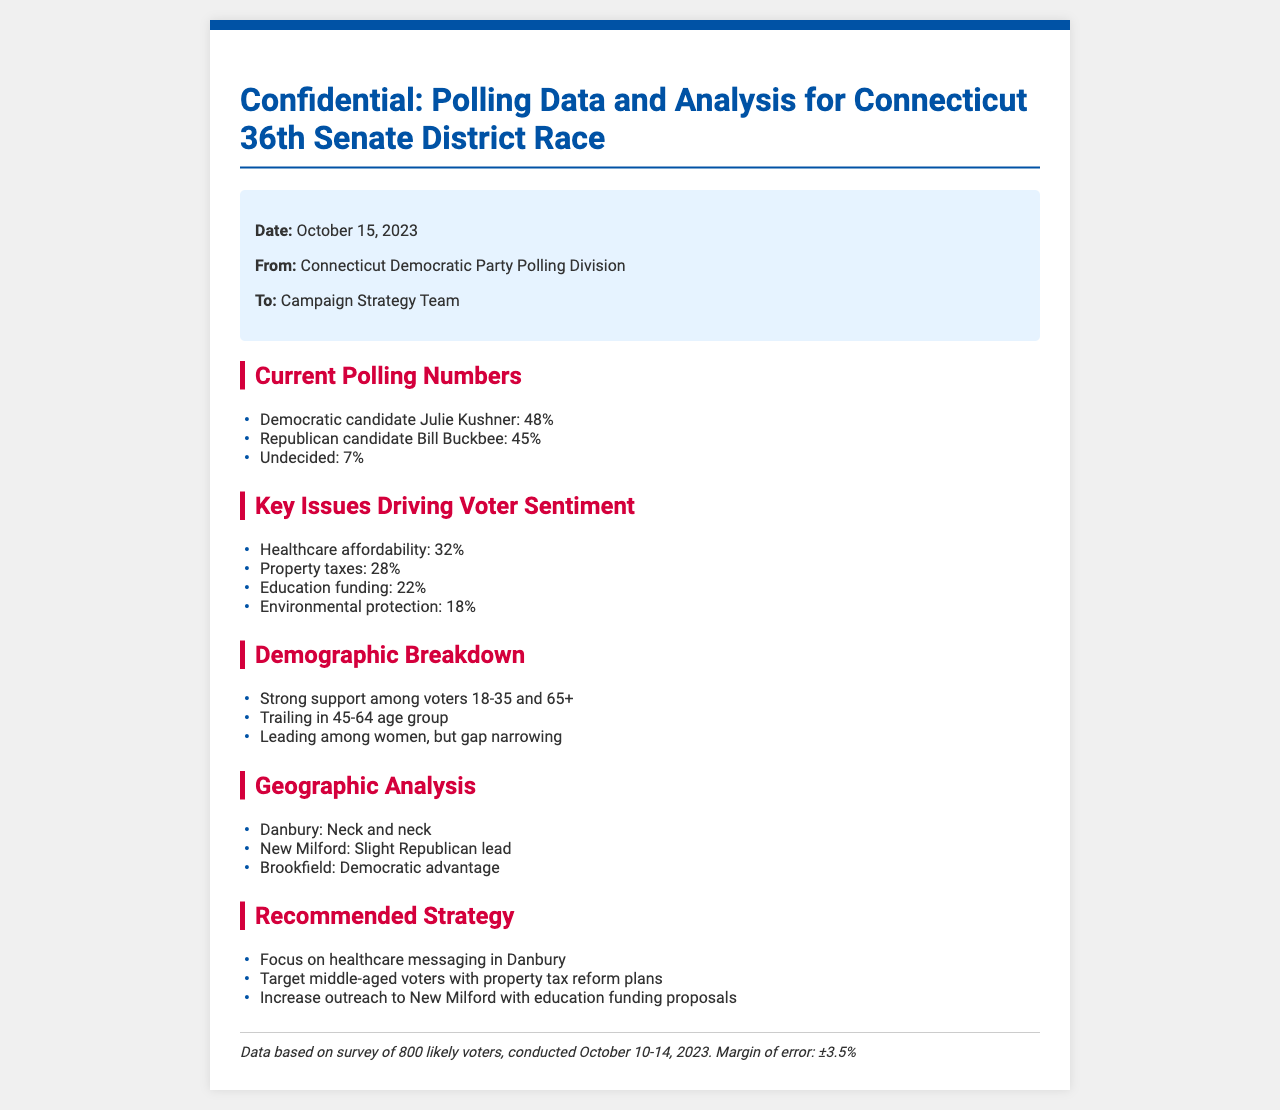What is the polling percentage for Julie Kushner? The document states that Julie Kushner has a polling percentage of 48%.
Answer: 48% What is the margin of error for the survey? The margin of error is explicitly stated in the footer as ±3.5%.
Answer: ±3.5% Which issue has the highest percentage of voter concern? The document lists healthcare affordability as the issue with the highest concern at 32%.
Answer: Healthcare affordability In which age group does Julie Kushner trail in support? The demographic section notes that Julie Kushner is trailing in the 45-64 age group.
Answer: 45-64 age group What strategy is recommended for outreach in New Milford? The document advises to increase outreach in New Milford with education funding proposals.
Answer: Education funding proposals Which town shows a neck-and-neck race? The geographic analysis mentions that Danbury is neck and neck in the polling.
Answer: Danbury What percentage of voters are currently undecided? The polling numbers indicate that 7% of voters are currently undecided.
Answer: 7% What is the date of the polling data? The date of the polling data is October 15, 2023, as noted in the metadata section.
Answer: October 15, 2023 